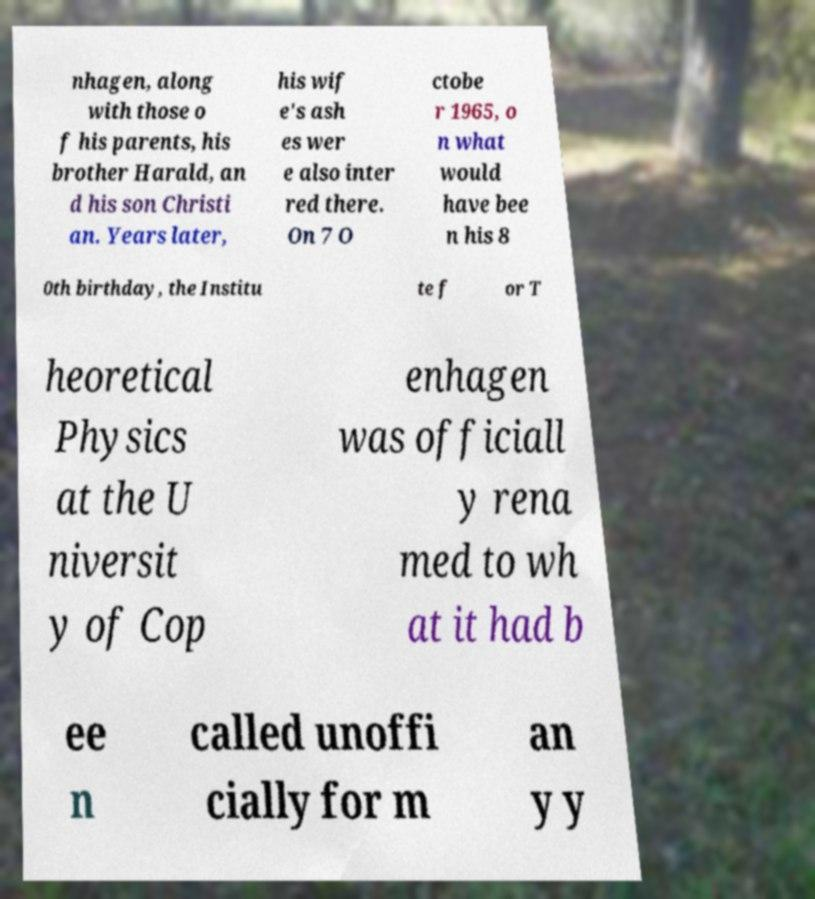What messages or text are displayed in this image? I need them in a readable, typed format. nhagen, along with those o f his parents, his brother Harald, an d his son Christi an. Years later, his wif e's ash es wer e also inter red there. On 7 O ctobe r 1965, o n what would have bee n his 8 0th birthday, the Institu te f or T heoretical Physics at the U niversit y of Cop enhagen was officiall y rena med to wh at it had b ee n called unoffi cially for m an y y 